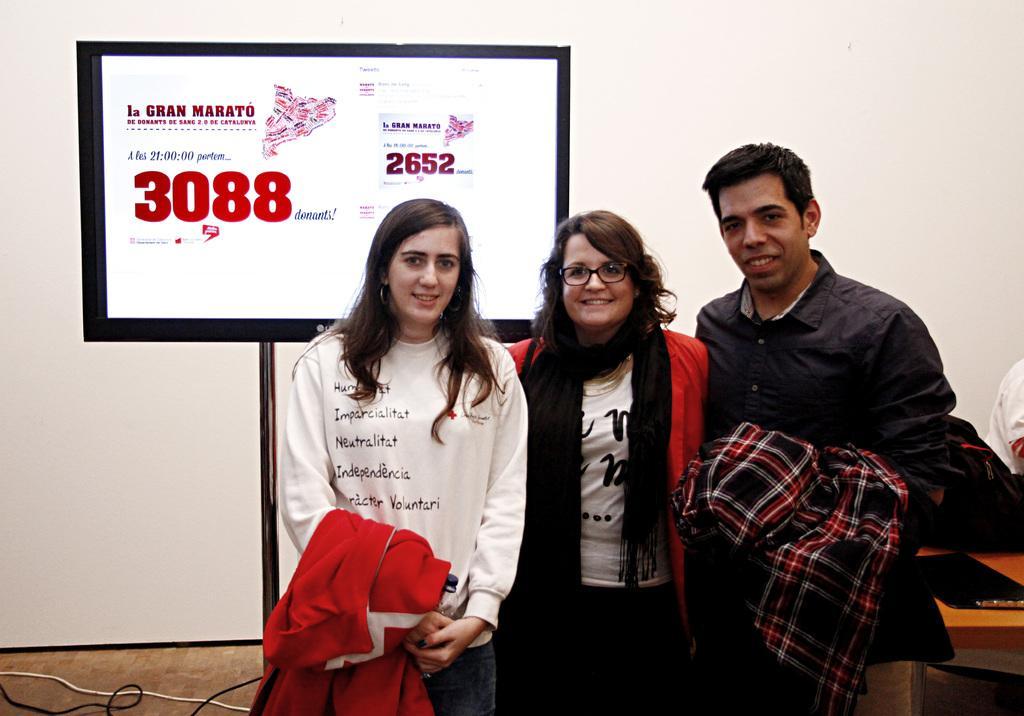Please provide a concise description of this image. As we can see in the image there is a white color wall, screen, few people standing in the front and a table. On table there is a laptop. 